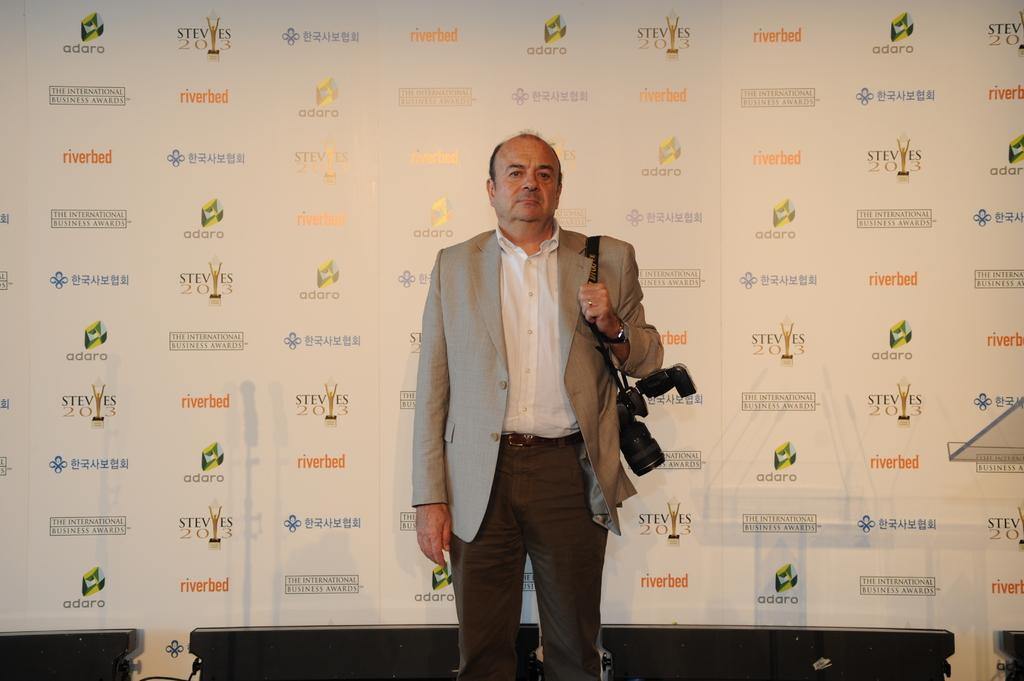In one or two sentences, can you explain what this image depicts? In this picture there is a man who is wearing blazer, shirt and trouser. He is holding the camera. In the bank we can see the banner, in that we can see different companies logo and name. On the right there is a speech desk. At the bottom i can see some black objects and cables. 